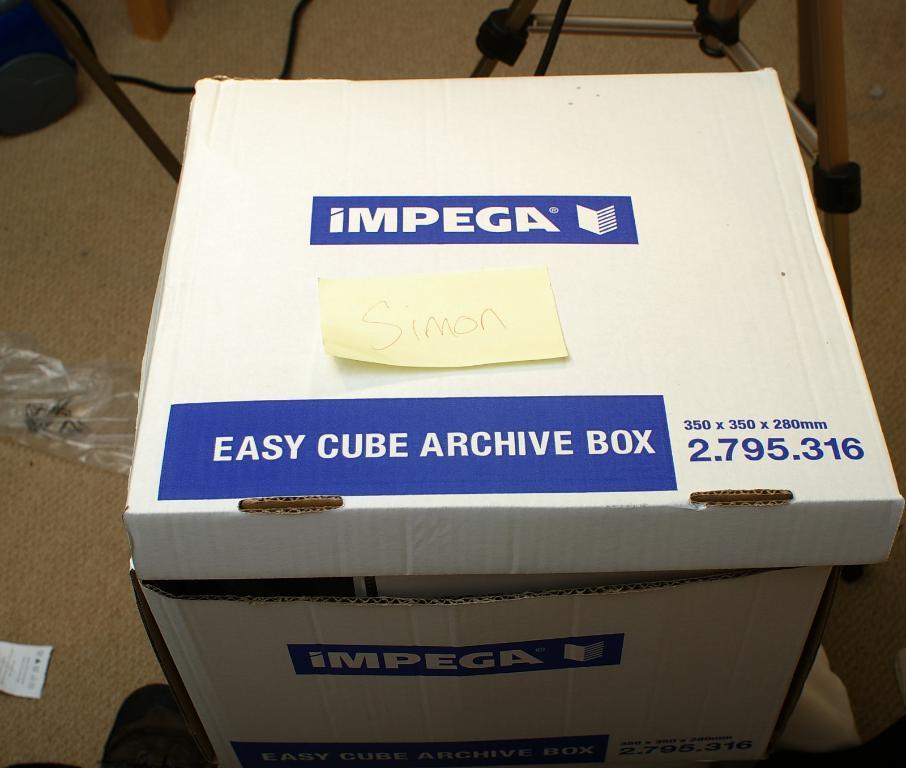What company made this box?
Provide a succinct answer. Impega. What name is on the note on top of the box?
Offer a terse response. Simon. 